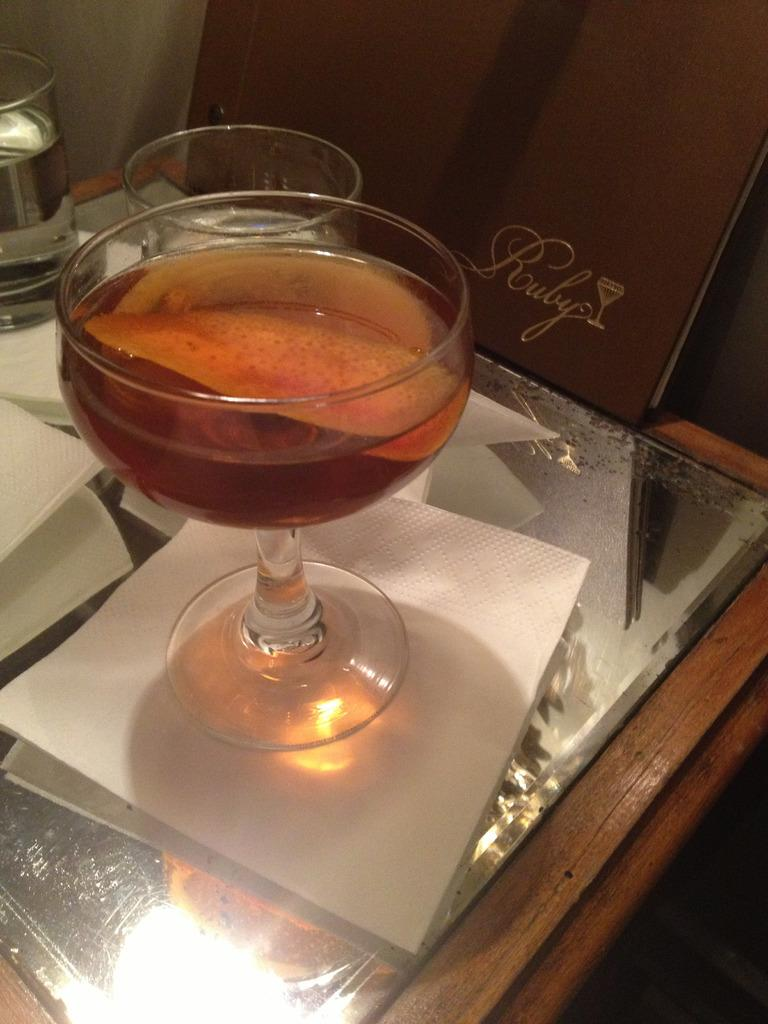What material is the table made of in the image? The table is made of wood. What type of table is it based on the material? The table is a wooden table. What is placed on the table? A glass and a tissue are placed on the table. Are there any other glasses visible in the image? Yes, there is another glass in the left corner of the table. Reasoning: Let' Let's think step by step in order to produce the conversation. We start by identifying the main subject in the image, which is the table. Then, we describe the table's material and type based on the provided facts. Next, we mention the items placed on the table, which are a glass and a tissue. Finally, we expand the conversation to include another glass visible in the image. Absurd Question/Answer: What type of mask is being worn by the table in the image? There is no mask or any person wearing a mask in the image. The subject is a table, and it does not have the ability to wear anything. 